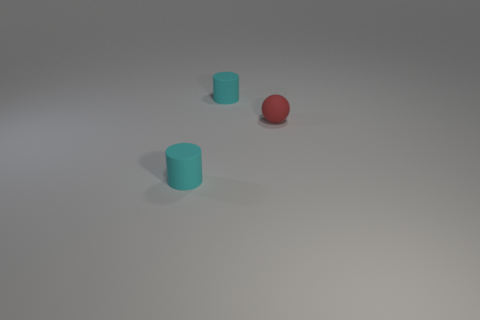Add 2 small red objects. How many objects exist? 5 Subtract all cylinders. How many objects are left? 1 Add 1 red rubber objects. How many red rubber objects are left? 2 Add 2 spheres. How many spheres exist? 3 Subtract 1 red spheres. How many objects are left? 2 Subtract all cyan rubber things. Subtract all red matte objects. How many objects are left? 0 